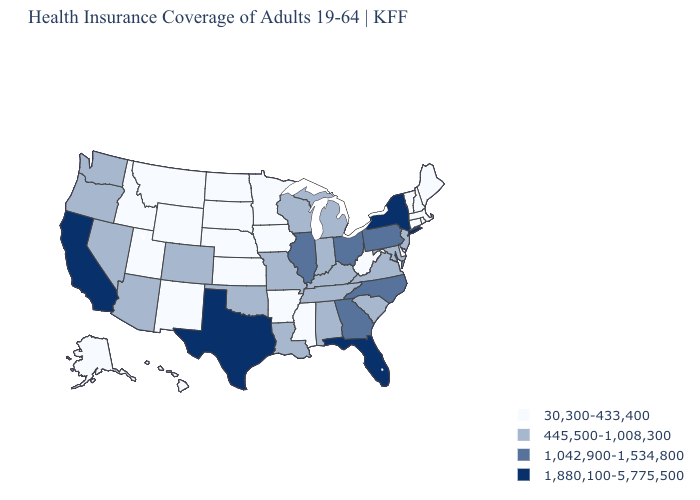Name the states that have a value in the range 1,042,900-1,534,800?
Write a very short answer. Georgia, Illinois, North Carolina, Ohio, Pennsylvania. Does the map have missing data?
Write a very short answer. No. Which states have the lowest value in the West?
Concise answer only. Alaska, Hawaii, Idaho, Montana, New Mexico, Utah, Wyoming. Name the states that have a value in the range 445,500-1,008,300?
Answer briefly. Alabama, Arizona, Colorado, Indiana, Kentucky, Louisiana, Maryland, Michigan, Missouri, Nevada, New Jersey, Oklahoma, Oregon, South Carolina, Tennessee, Virginia, Washington, Wisconsin. Name the states that have a value in the range 30,300-433,400?
Write a very short answer. Alaska, Arkansas, Connecticut, Delaware, Hawaii, Idaho, Iowa, Kansas, Maine, Massachusetts, Minnesota, Mississippi, Montana, Nebraska, New Hampshire, New Mexico, North Dakota, Rhode Island, South Dakota, Utah, Vermont, West Virginia, Wyoming. Which states hav the highest value in the West?
Be succinct. California. What is the value of Michigan?
Write a very short answer. 445,500-1,008,300. Which states have the highest value in the USA?
Give a very brief answer. California, Florida, New York, Texas. Which states have the highest value in the USA?
Write a very short answer. California, Florida, New York, Texas. Does Vermont have the lowest value in the Northeast?
Concise answer only. Yes. Among the states that border West Virginia , does Maryland have the highest value?
Quick response, please. No. What is the lowest value in the USA?
Give a very brief answer. 30,300-433,400. Among the states that border Pennsylvania , does Maryland have the lowest value?
Keep it brief. No. What is the highest value in the Northeast ?
Quick response, please. 1,880,100-5,775,500. Does New Hampshire have the lowest value in the Northeast?
Answer briefly. Yes. 